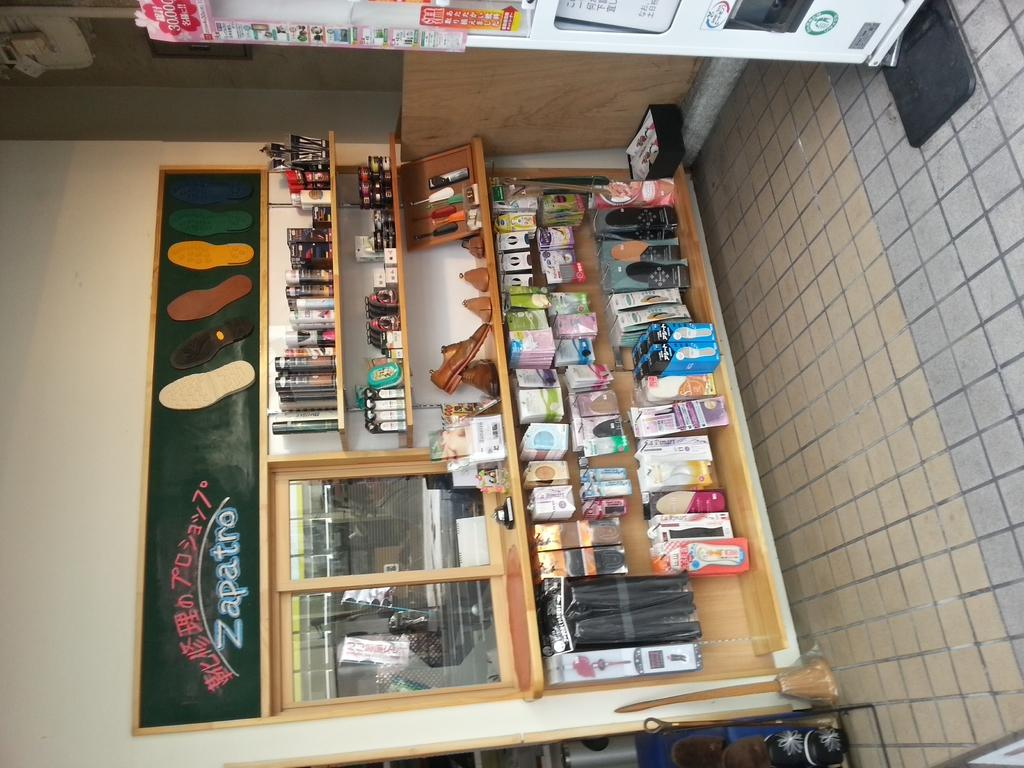<image>
Offer a succinct explanation of the picture presented. A store with a sign that reads "Zapatro" has various goods on display. 